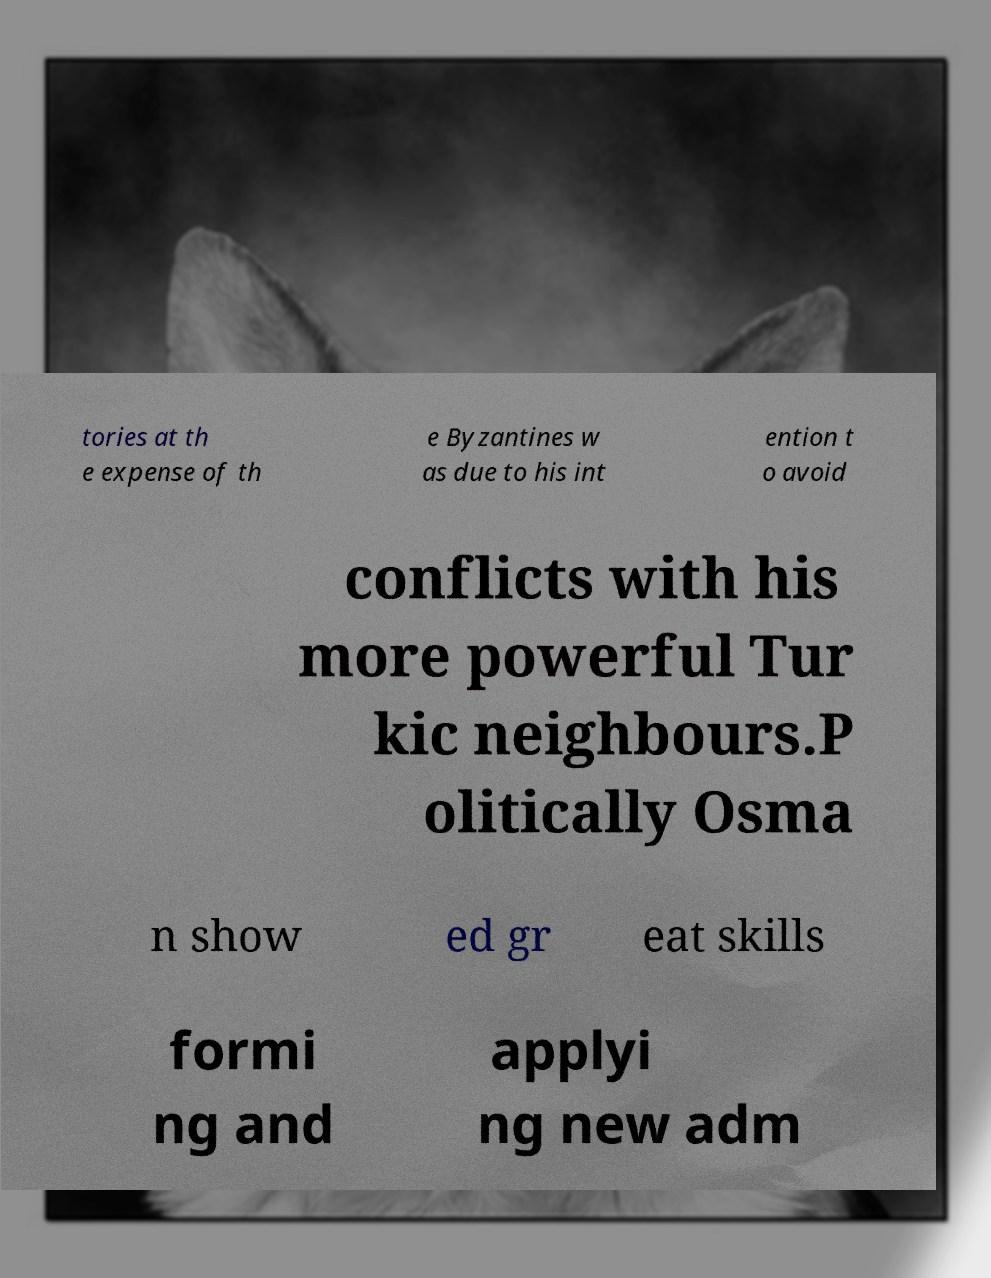Could you assist in decoding the text presented in this image and type it out clearly? tories at th e expense of th e Byzantines w as due to his int ention t o avoid conflicts with his more powerful Tur kic neighbours.P olitically Osma n show ed gr eat skills formi ng and applyi ng new adm 